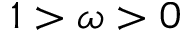Convert formula to latex. <formula><loc_0><loc_0><loc_500><loc_500>1 > \omega > 0</formula> 